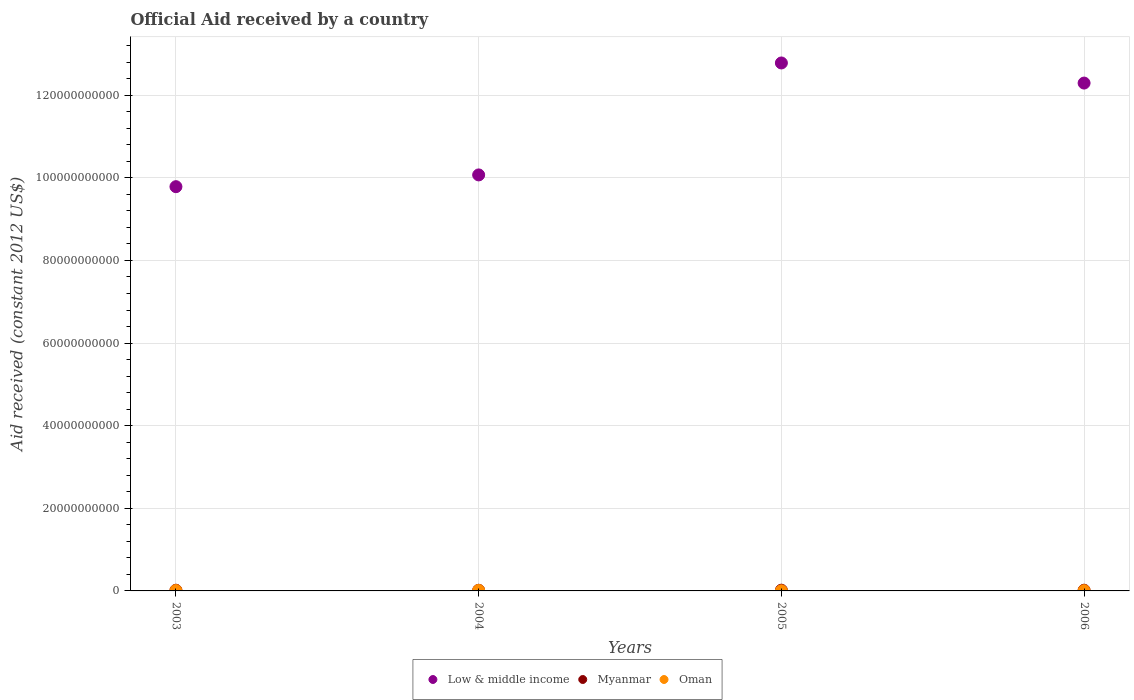How many different coloured dotlines are there?
Your answer should be very brief. 3. Is the number of dotlines equal to the number of legend labels?
Keep it short and to the point. Yes. What is the net official aid received in Oman in 2003?
Provide a short and direct response. 8.68e+07. Across all years, what is the maximum net official aid received in Oman?
Offer a very short reply. 1.23e+08. Across all years, what is the minimum net official aid received in Myanmar?
Give a very brief answer. 1.58e+08. In which year was the net official aid received in Myanmar maximum?
Make the answer very short. 2005. In which year was the net official aid received in Oman minimum?
Offer a very short reply. 2005. What is the total net official aid received in Low & middle income in the graph?
Provide a succinct answer. 4.49e+11. What is the difference between the net official aid received in Low & middle income in 2003 and that in 2006?
Give a very brief answer. -2.51e+1. What is the difference between the net official aid received in Oman in 2006 and the net official aid received in Myanmar in 2003?
Give a very brief answer. -1.07e+08. What is the average net official aid received in Oman per year?
Your response must be concise. 7.42e+07. In the year 2005, what is the difference between the net official aid received in Myanmar and net official aid received in Low & middle income?
Provide a succinct answer. -1.28e+11. In how many years, is the net official aid received in Oman greater than 68000000000 US$?
Offer a very short reply. 0. What is the ratio of the net official aid received in Myanmar in 2003 to that in 2006?
Provide a succinct answer. 0.97. Is the net official aid received in Oman in 2004 less than that in 2006?
Provide a succinct answer. No. What is the difference between the highest and the second highest net official aid received in Low & middle income?
Keep it short and to the point. 4.87e+09. What is the difference between the highest and the lowest net official aid received in Oman?
Your answer should be compact. 1.00e+08. Is it the case that in every year, the sum of the net official aid received in Low & middle income and net official aid received in Oman  is greater than the net official aid received in Myanmar?
Offer a terse response. Yes. Is the net official aid received in Myanmar strictly less than the net official aid received in Oman over the years?
Provide a succinct answer. No. How many years are there in the graph?
Provide a short and direct response. 4. Are the values on the major ticks of Y-axis written in scientific E-notation?
Your answer should be very brief. No. Does the graph contain any zero values?
Keep it short and to the point. No. Does the graph contain grids?
Keep it short and to the point. Yes. Where does the legend appear in the graph?
Give a very brief answer. Bottom center. How many legend labels are there?
Your response must be concise. 3. How are the legend labels stacked?
Ensure brevity in your answer.  Horizontal. What is the title of the graph?
Keep it short and to the point. Official Aid received by a country. Does "Low & middle income" appear as one of the legend labels in the graph?
Give a very brief answer. Yes. What is the label or title of the X-axis?
Offer a very short reply. Years. What is the label or title of the Y-axis?
Give a very brief answer. Aid received (constant 2012 US$). What is the Aid received (constant 2012 US$) in Low & middle income in 2003?
Give a very brief answer. 9.79e+1. What is the Aid received (constant 2012 US$) in Myanmar in 2003?
Ensure brevity in your answer.  1.71e+08. What is the Aid received (constant 2012 US$) of Oman in 2003?
Keep it short and to the point. 8.68e+07. What is the Aid received (constant 2012 US$) of Low & middle income in 2004?
Make the answer very short. 1.01e+11. What is the Aid received (constant 2012 US$) in Myanmar in 2004?
Give a very brief answer. 1.58e+08. What is the Aid received (constant 2012 US$) in Oman in 2004?
Your answer should be very brief. 1.23e+08. What is the Aid received (constant 2012 US$) of Low & middle income in 2005?
Make the answer very short. 1.28e+11. What is the Aid received (constant 2012 US$) in Myanmar in 2005?
Offer a terse response. 1.79e+08. What is the Aid received (constant 2012 US$) of Oman in 2005?
Ensure brevity in your answer.  2.30e+07. What is the Aid received (constant 2012 US$) of Low & middle income in 2006?
Give a very brief answer. 1.23e+11. What is the Aid received (constant 2012 US$) in Myanmar in 2006?
Give a very brief answer. 1.75e+08. What is the Aid received (constant 2012 US$) of Oman in 2006?
Ensure brevity in your answer.  6.37e+07. Across all years, what is the maximum Aid received (constant 2012 US$) in Low & middle income?
Make the answer very short. 1.28e+11. Across all years, what is the maximum Aid received (constant 2012 US$) of Myanmar?
Offer a very short reply. 1.79e+08. Across all years, what is the maximum Aid received (constant 2012 US$) of Oman?
Provide a short and direct response. 1.23e+08. Across all years, what is the minimum Aid received (constant 2012 US$) of Low & middle income?
Your answer should be compact. 9.79e+1. Across all years, what is the minimum Aid received (constant 2012 US$) of Myanmar?
Your answer should be compact. 1.58e+08. Across all years, what is the minimum Aid received (constant 2012 US$) of Oman?
Provide a short and direct response. 2.30e+07. What is the total Aid received (constant 2012 US$) in Low & middle income in the graph?
Your response must be concise. 4.49e+11. What is the total Aid received (constant 2012 US$) in Myanmar in the graph?
Provide a succinct answer. 6.83e+08. What is the total Aid received (constant 2012 US$) in Oman in the graph?
Ensure brevity in your answer.  2.97e+08. What is the difference between the Aid received (constant 2012 US$) in Low & middle income in 2003 and that in 2004?
Your answer should be compact. -2.85e+09. What is the difference between the Aid received (constant 2012 US$) of Myanmar in 2003 and that in 2004?
Your answer should be compact. 1.27e+07. What is the difference between the Aid received (constant 2012 US$) in Oman in 2003 and that in 2004?
Ensure brevity in your answer.  -3.64e+07. What is the difference between the Aid received (constant 2012 US$) of Low & middle income in 2003 and that in 2005?
Make the answer very short. -2.99e+1. What is the difference between the Aid received (constant 2012 US$) of Myanmar in 2003 and that in 2005?
Keep it short and to the point. -7.76e+06. What is the difference between the Aid received (constant 2012 US$) of Oman in 2003 and that in 2005?
Keep it short and to the point. 6.38e+07. What is the difference between the Aid received (constant 2012 US$) of Low & middle income in 2003 and that in 2006?
Give a very brief answer. -2.51e+1. What is the difference between the Aid received (constant 2012 US$) in Myanmar in 2003 and that in 2006?
Your response must be concise. -4.54e+06. What is the difference between the Aid received (constant 2012 US$) of Oman in 2003 and that in 2006?
Give a very brief answer. 2.30e+07. What is the difference between the Aid received (constant 2012 US$) in Low & middle income in 2004 and that in 2005?
Your answer should be compact. -2.71e+1. What is the difference between the Aid received (constant 2012 US$) of Myanmar in 2004 and that in 2005?
Offer a terse response. -2.05e+07. What is the difference between the Aid received (constant 2012 US$) of Oman in 2004 and that in 2005?
Offer a terse response. 1.00e+08. What is the difference between the Aid received (constant 2012 US$) of Low & middle income in 2004 and that in 2006?
Ensure brevity in your answer.  -2.22e+1. What is the difference between the Aid received (constant 2012 US$) of Myanmar in 2004 and that in 2006?
Your answer should be very brief. -1.73e+07. What is the difference between the Aid received (constant 2012 US$) of Oman in 2004 and that in 2006?
Make the answer very short. 5.94e+07. What is the difference between the Aid received (constant 2012 US$) of Low & middle income in 2005 and that in 2006?
Offer a terse response. 4.87e+09. What is the difference between the Aid received (constant 2012 US$) of Myanmar in 2005 and that in 2006?
Offer a very short reply. 3.22e+06. What is the difference between the Aid received (constant 2012 US$) in Oman in 2005 and that in 2006?
Provide a short and direct response. -4.08e+07. What is the difference between the Aid received (constant 2012 US$) of Low & middle income in 2003 and the Aid received (constant 2012 US$) of Myanmar in 2004?
Provide a succinct answer. 9.77e+1. What is the difference between the Aid received (constant 2012 US$) in Low & middle income in 2003 and the Aid received (constant 2012 US$) in Oman in 2004?
Provide a short and direct response. 9.77e+1. What is the difference between the Aid received (constant 2012 US$) of Myanmar in 2003 and the Aid received (constant 2012 US$) of Oman in 2004?
Provide a short and direct response. 4.78e+07. What is the difference between the Aid received (constant 2012 US$) in Low & middle income in 2003 and the Aid received (constant 2012 US$) in Myanmar in 2005?
Provide a succinct answer. 9.77e+1. What is the difference between the Aid received (constant 2012 US$) of Low & middle income in 2003 and the Aid received (constant 2012 US$) of Oman in 2005?
Your answer should be very brief. 9.78e+1. What is the difference between the Aid received (constant 2012 US$) of Myanmar in 2003 and the Aid received (constant 2012 US$) of Oman in 2005?
Provide a short and direct response. 1.48e+08. What is the difference between the Aid received (constant 2012 US$) of Low & middle income in 2003 and the Aid received (constant 2012 US$) of Myanmar in 2006?
Provide a succinct answer. 9.77e+1. What is the difference between the Aid received (constant 2012 US$) of Low & middle income in 2003 and the Aid received (constant 2012 US$) of Oman in 2006?
Ensure brevity in your answer.  9.78e+1. What is the difference between the Aid received (constant 2012 US$) in Myanmar in 2003 and the Aid received (constant 2012 US$) in Oman in 2006?
Offer a terse response. 1.07e+08. What is the difference between the Aid received (constant 2012 US$) of Low & middle income in 2004 and the Aid received (constant 2012 US$) of Myanmar in 2005?
Keep it short and to the point. 1.01e+11. What is the difference between the Aid received (constant 2012 US$) of Low & middle income in 2004 and the Aid received (constant 2012 US$) of Oman in 2005?
Offer a very short reply. 1.01e+11. What is the difference between the Aid received (constant 2012 US$) of Myanmar in 2004 and the Aid received (constant 2012 US$) of Oman in 2005?
Provide a short and direct response. 1.35e+08. What is the difference between the Aid received (constant 2012 US$) of Low & middle income in 2004 and the Aid received (constant 2012 US$) of Myanmar in 2006?
Your response must be concise. 1.01e+11. What is the difference between the Aid received (constant 2012 US$) in Low & middle income in 2004 and the Aid received (constant 2012 US$) in Oman in 2006?
Keep it short and to the point. 1.01e+11. What is the difference between the Aid received (constant 2012 US$) in Myanmar in 2004 and the Aid received (constant 2012 US$) in Oman in 2006?
Keep it short and to the point. 9.45e+07. What is the difference between the Aid received (constant 2012 US$) in Low & middle income in 2005 and the Aid received (constant 2012 US$) in Myanmar in 2006?
Offer a terse response. 1.28e+11. What is the difference between the Aid received (constant 2012 US$) of Low & middle income in 2005 and the Aid received (constant 2012 US$) of Oman in 2006?
Offer a terse response. 1.28e+11. What is the difference between the Aid received (constant 2012 US$) of Myanmar in 2005 and the Aid received (constant 2012 US$) of Oman in 2006?
Make the answer very short. 1.15e+08. What is the average Aid received (constant 2012 US$) of Low & middle income per year?
Offer a very short reply. 1.12e+11. What is the average Aid received (constant 2012 US$) in Myanmar per year?
Offer a very short reply. 1.71e+08. What is the average Aid received (constant 2012 US$) in Oman per year?
Offer a very short reply. 7.42e+07. In the year 2003, what is the difference between the Aid received (constant 2012 US$) of Low & middle income and Aid received (constant 2012 US$) of Myanmar?
Your response must be concise. 9.77e+1. In the year 2003, what is the difference between the Aid received (constant 2012 US$) in Low & middle income and Aid received (constant 2012 US$) in Oman?
Give a very brief answer. 9.78e+1. In the year 2003, what is the difference between the Aid received (constant 2012 US$) of Myanmar and Aid received (constant 2012 US$) of Oman?
Keep it short and to the point. 8.42e+07. In the year 2004, what is the difference between the Aid received (constant 2012 US$) in Low & middle income and Aid received (constant 2012 US$) in Myanmar?
Provide a short and direct response. 1.01e+11. In the year 2004, what is the difference between the Aid received (constant 2012 US$) in Low & middle income and Aid received (constant 2012 US$) in Oman?
Provide a succinct answer. 1.01e+11. In the year 2004, what is the difference between the Aid received (constant 2012 US$) in Myanmar and Aid received (constant 2012 US$) in Oman?
Your answer should be very brief. 3.51e+07. In the year 2005, what is the difference between the Aid received (constant 2012 US$) of Low & middle income and Aid received (constant 2012 US$) of Myanmar?
Provide a short and direct response. 1.28e+11. In the year 2005, what is the difference between the Aid received (constant 2012 US$) of Low & middle income and Aid received (constant 2012 US$) of Oman?
Provide a short and direct response. 1.28e+11. In the year 2005, what is the difference between the Aid received (constant 2012 US$) in Myanmar and Aid received (constant 2012 US$) in Oman?
Your response must be concise. 1.56e+08. In the year 2006, what is the difference between the Aid received (constant 2012 US$) in Low & middle income and Aid received (constant 2012 US$) in Myanmar?
Offer a very short reply. 1.23e+11. In the year 2006, what is the difference between the Aid received (constant 2012 US$) in Low & middle income and Aid received (constant 2012 US$) in Oman?
Give a very brief answer. 1.23e+11. In the year 2006, what is the difference between the Aid received (constant 2012 US$) in Myanmar and Aid received (constant 2012 US$) in Oman?
Keep it short and to the point. 1.12e+08. What is the ratio of the Aid received (constant 2012 US$) of Low & middle income in 2003 to that in 2004?
Your response must be concise. 0.97. What is the ratio of the Aid received (constant 2012 US$) in Myanmar in 2003 to that in 2004?
Your response must be concise. 1.08. What is the ratio of the Aid received (constant 2012 US$) in Oman in 2003 to that in 2004?
Your answer should be compact. 0.7. What is the ratio of the Aid received (constant 2012 US$) of Low & middle income in 2003 to that in 2005?
Keep it short and to the point. 0.77. What is the ratio of the Aid received (constant 2012 US$) of Myanmar in 2003 to that in 2005?
Ensure brevity in your answer.  0.96. What is the ratio of the Aid received (constant 2012 US$) in Oman in 2003 to that in 2005?
Make the answer very short. 3.77. What is the ratio of the Aid received (constant 2012 US$) of Low & middle income in 2003 to that in 2006?
Ensure brevity in your answer.  0.8. What is the ratio of the Aid received (constant 2012 US$) in Myanmar in 2003 to that in 2006?
Keep it short and to the point. 0.97. What is the ratio of the Aid received (constant 2012 US$) of Oman in 2003 to that in 2006?
Offer a terse response. 1.36. What is the ratio of the Aid received (constant 2012 US$) in Low & middle income in 2004 to that in 2005?
Make the answer very short. 0.79. What is the ratio of the Aid received (constant 2012 US$) of Myanmar in 2004 to that in 2005?
Provide a short and direct response. 0.89. What is the ratio of the Aid received (constant 2012 US$) of Oman in 2004 to that in 2005?
Provide a succinct answer. 5.36. What is the ratio of the Aid received (constant 2012 US$) of Low & middle income in 2004 to that in 2006?
Offer a terse response. 0.82. What is the ratio of the Aid received (constant 2012 US$) of Myanmar in 2004 to that in 2006?
Keep it short and to the point. 0.9. What is the ratio of the Aid received (constant 2012 US$) of Oman in 2004 to that in 2006?
Give a very brief answer. 1.93. What is the ratio of the Aid received (constant 2012 US$) in Low & middle income in 2005 to that in 2006?
Provide a short and direct response. 1.04. What is the ratio of the Aid received (constant 2012 US$) of Myanmar in 2005 to that in 2006?
Make the answer very short. 1.02. What is the ratio of the Aid received (constant 2012 US$) in Oman in 2005 to that in 2006?
Your response must be concise. 0.36. What is the difference between the highest and the second highest Aid received (constant 2012 US$) of Low & middle income?
Make the answer very short. 4.87e+09. What is the difference between the highest and the second highest Aid received (constant 2012 US$) of Myanmar?
Make the answer very short. 3.22e+06. What is the difference between the highest and the second highest Aid received (constant 2012 US$) in Oman?
Provide a succinct answer. 3.64e+07. What is the difference between the highest and the lowest Aid received (constant 2012 US$) in Low & middle income?
Make the answer very short. 2.99e+1. What is the difference between the highest and the lowest Aid received (constant 2012 US$) of Myanmar?
Make the answer very short. 2.05e+07. What is the difference between the highest and the lowest Aid received (constant 2012 US$) in Oman?
Give a very brief answer. 1.00e+08. 